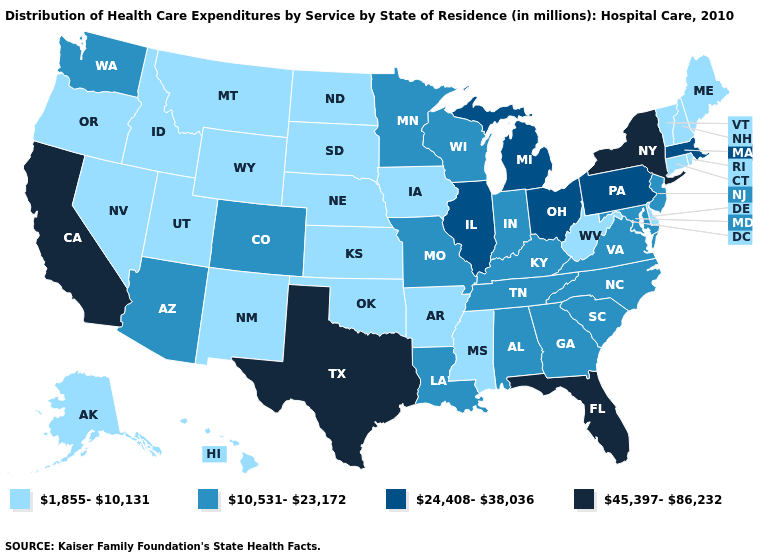What is the highest value in the USA?
Quick response, please. 45,397-86,232. Name the states that have a value in the range 24,408-38,036?
Keep it brief. Illinois, Massachusetts, Michigan, Ohio, Pennsylvania. Name the states that have a value in the range 1,855-10,131?
Answer briefly. Alaska, Arkansas, Connecticut, Delaware, Hawaii, Idaho, Iowa, Kansas, Maine, Mississippi, Montana, Nebraska, Nevada, New Hampshire, New Mexico, North Dakota, Oklahoma, Oregon, Rhode Island, South Dakota, Utah, Vermont, West Virginia, Wyoming. What is the value of Arkansas?
Give a very brief answer. 1,855-10,131. What is the value of Mississippi?
Answer briefly. 1,855-10,131. What is the value of Rhode Island?
Short answer required. 1,855-10,131. What is the highest value in the West ?
Concise answer only. 45,397-86,232. Among the states that border Kentucky , which have the highest value?
Short answer required. Illinois, Ohio. Name the states that have a value in the range 10,531-23,172?
Concise answer only. Alabama, Arizona, Colorado, Georgia, Indiana, Kentucky, Louisiana, Maryland, Minnesota, Missouri, New Jersey, North Carolina, South Carolina, Tennessee, Virginia, Washington, Wisconsin. Does California have the highest value in the USA?
Concise answer only. Yes. Is the legend a continuous bar?
Answer briefly. No. What is the lowest value in states that border Iowa?
Keep it brief. 1,855-10,131. What is the value of West Virginia?
Answer briefly. 1,855-10,131. What is the value of Georgia?
Give a very brief answer. 10,531-23,172. What is the lowest value in the USA?
Concise answer only. 1,855-10,131. 